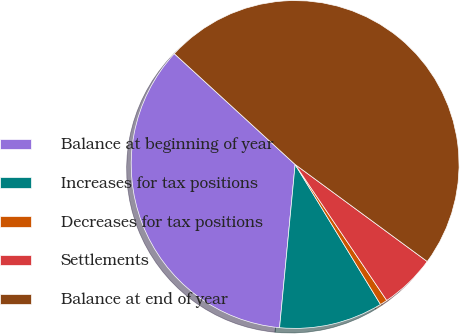<chart> <loc_0><loc_0><loc_500><loc_500><pie_chart><fcel>Balance at beginning of year<fcel>Increases for tax positions<fcel>Decreases for tax positions<fcel>Settlements<fcel>Balance at end of year<nl><fcel>35.3%<fcel>10.23%<fcel>0.72%<fcel>5.48%<fcel>48.27%<nl></chart> 